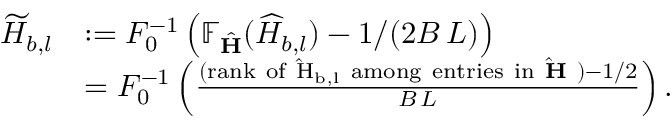<formula> <loc_0><loc_0><loc_500><loc_500>\begin{array} { r l } { \widetilde { H } _ { b , l } } & { \colon = F _ { 0 } ^ { - 1 } \left ( \mathbb { F } _ { \hat { H } } ( \widehat { H } _ { b , l } ) - 1 / ( 2 B \, L ) \right ) } \\ & { = F _ { 0 } ^ { - 1 } \left ( \frac { ( r a n k o f \hat { H } _ { b , l } a m o n g e n t r i e s i n \hat { H } ) - 1 / 2 } { B \, L } \right ) . } \end{array}</formula> 